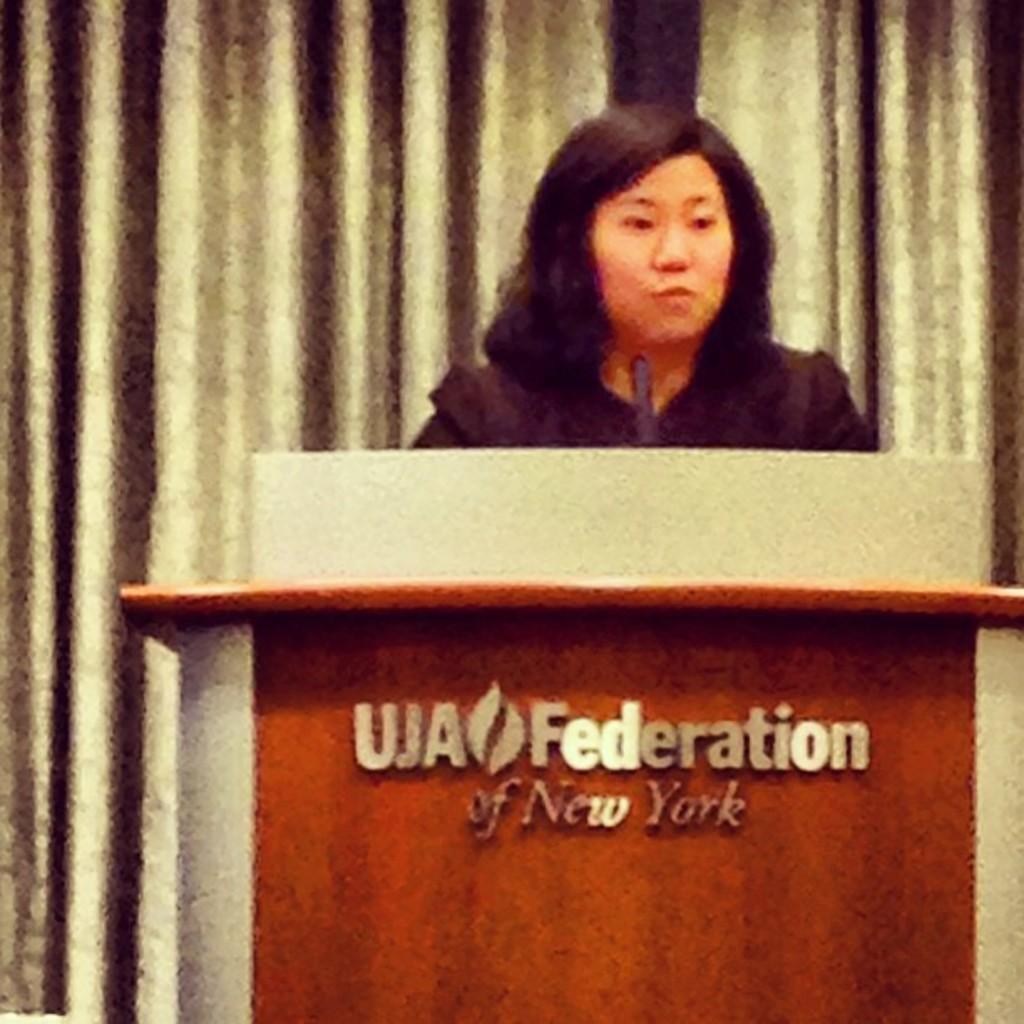Describe this image in one or two sentences. In the picture there is a woman present near the podium, there is a microphone present, on the podium there is a some text present, behind the woman there is curtain present. 